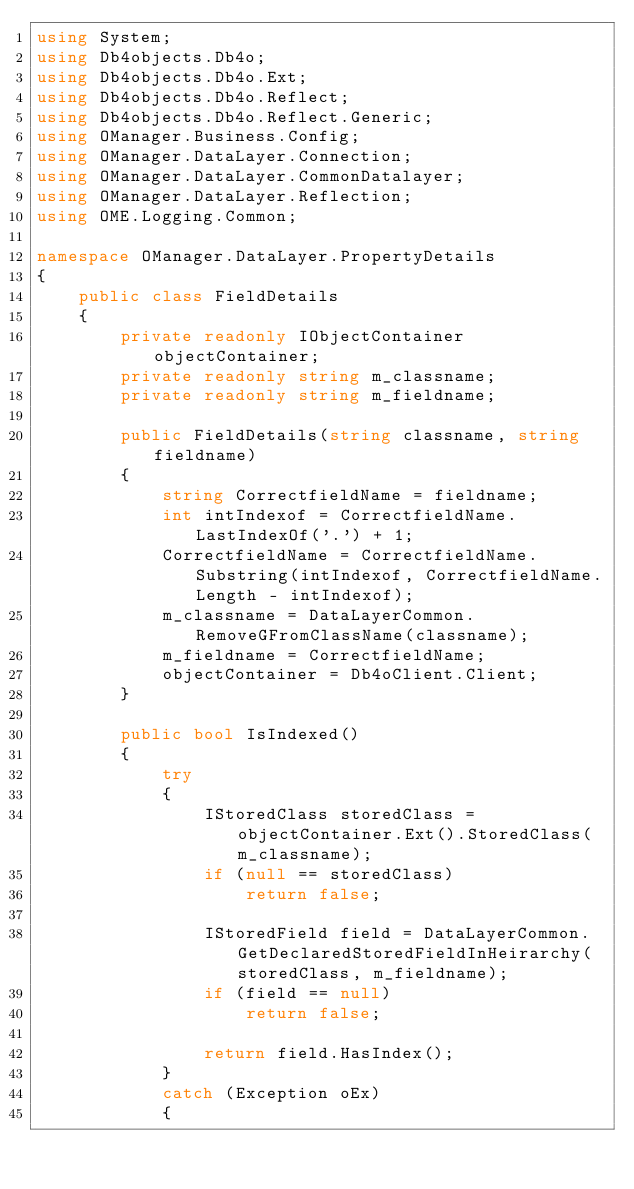<code> <loc_0><loc_0><loc_500><loc_500><_C#_>using System;
using Db4objects.Db4o;
using Db4objects.Db4o.Ext;
using Db4objects.Db4o.Reflect;
using Db4objects.Db4o.Reflect.Generic;
using OManager.Business.Config;
using OManager.DataLayer.Connection;
using OManager.DataLayer.CommonDatalayer;
using OManager.DataLayer.Reflection;
using OME.Logging.Common;

namespace OManager.DataLayer.PropertyDetails
{
    public class FieldDetails 
    {
        private readonly IObjectContainer objectContainer;
        private readonly string m_classname; 
        private readonly string m_fieldname;

        public FieldDetails(string classname, string fieldname)
        {
            string CorrectfieldName = fieldname;
            int intIndexof = CorrectfieldName.LastIndexOf('.') + 1;
            CorrectfieldName = CorrectfieldName.Substring(intIndexof, CorrectfieldName.Length - intIndexof);
            m_classname = DataLayerCommon.RemoveGFromClassName(classname);
            m_fieldname = CorrectfieldName;
            objectContainer = Db4oClient.Client; 
        }

        public bool IsIndexed()
        {
			try
			{
				IStoredClass storedClass = objectContainer.Ext().StoredClass(m_classname);
				if (null == storedClass)
					return false;

				IStoredField field = DataLayerCommon.GetDeclaredStoredFieldInHeirarchy(storedClass, m_fieldname);
				if (field == null)
					return false;

				return field.HasIndex();
			}
			catch (Exception oEx)
			{</code> 